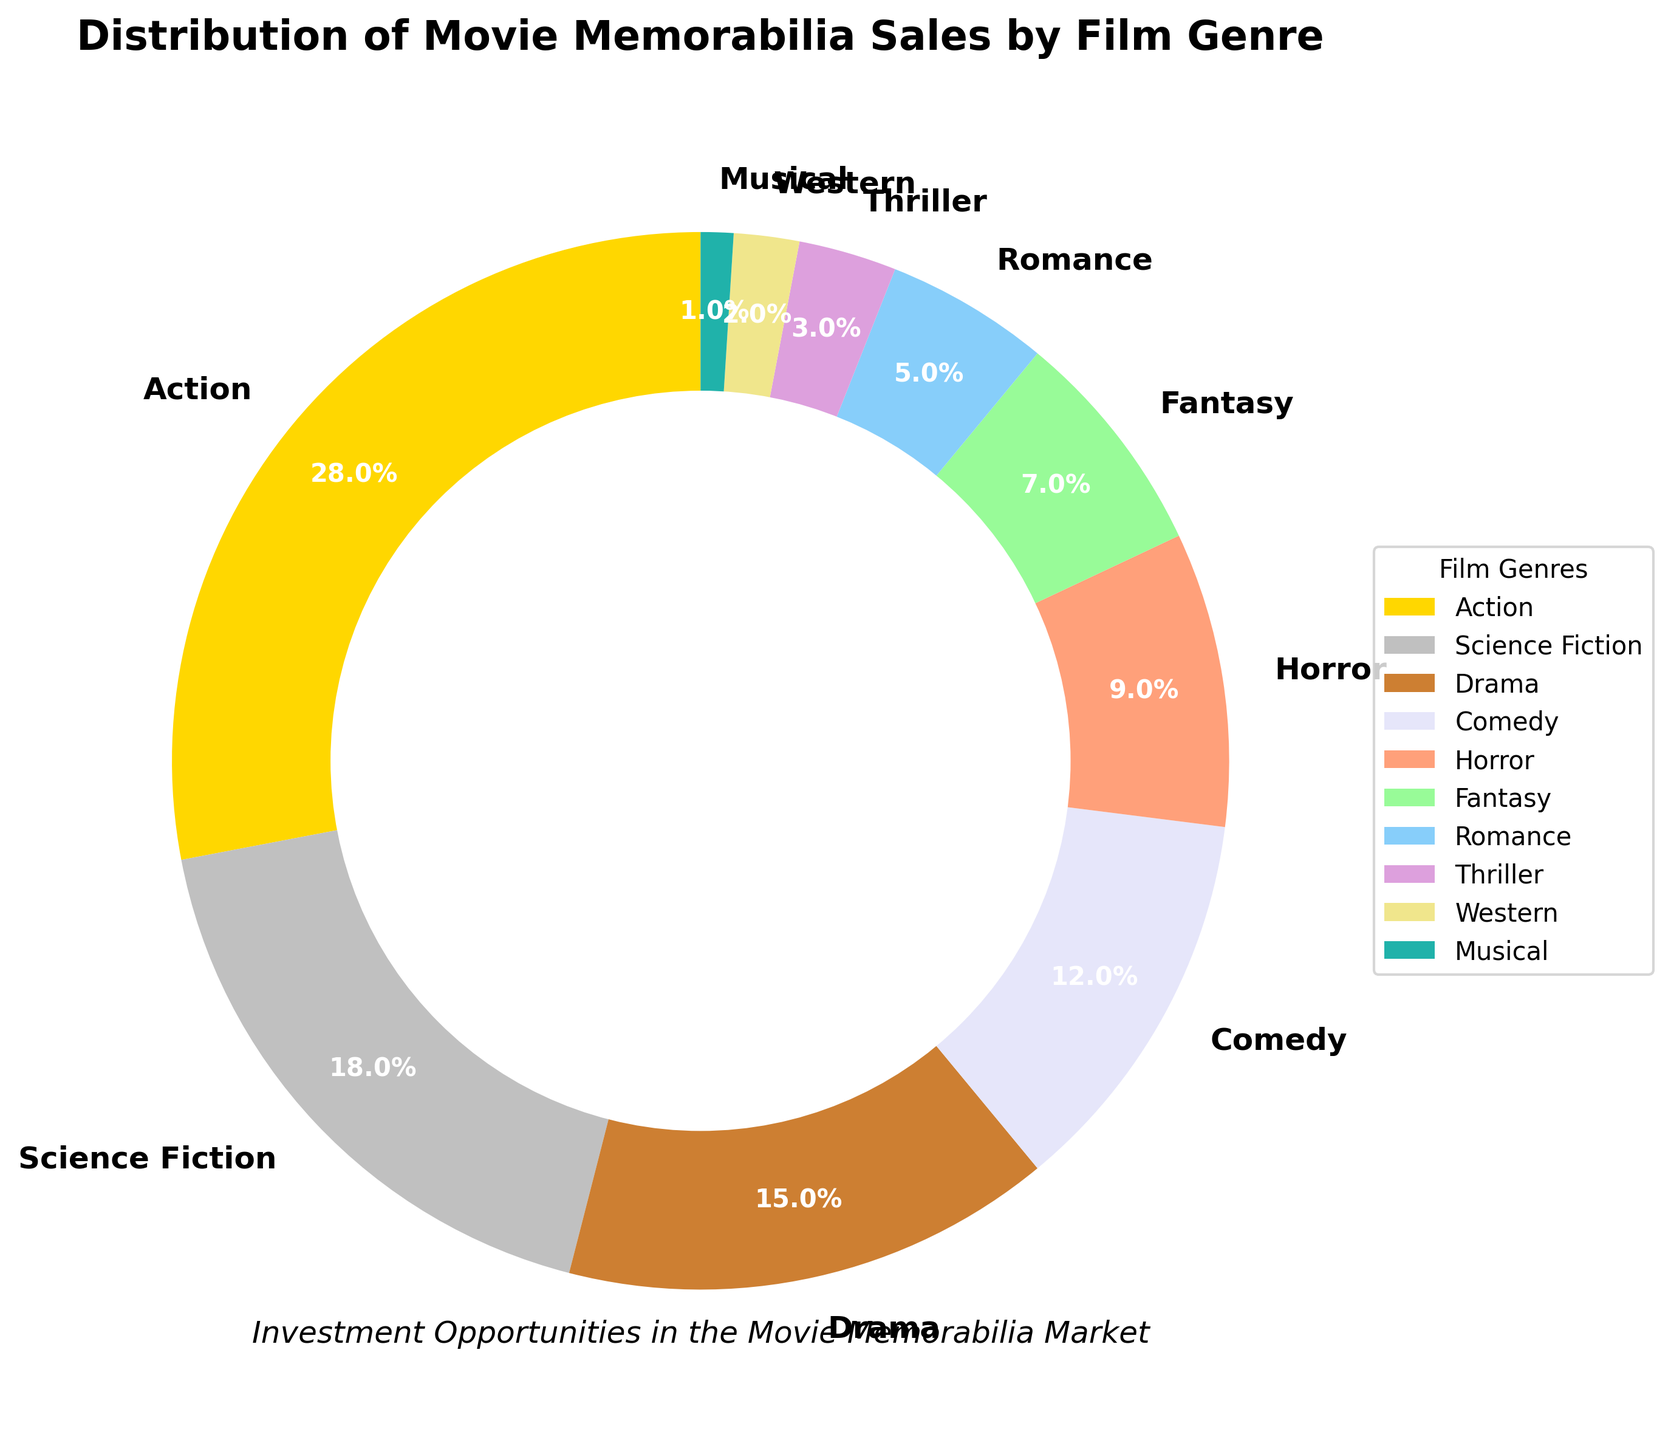Which genre has the highest percentage of movie memorabilia sales? The figure shows a pie chart where each wedge represents a percentage of movie memorabilia sales by genre. The largest wedge belongs to "Action" with 28%.
Answer: Action What is the combined market share of Science Fiction and Fantasy genres? According to the figure, Science Fiction has 18% and Fantasy has 7%. Adding these percentages gives 18 + 7 = 25%.
Answer: 25% Is the market share of Drama greater than Comedy? Based on the figure, Drama has 15% while Comedy has 12%. Since 15% is greater than 12%, Drama has a greater market share than Comedy.
Answer: Yes Which genre has a lower market share than Horror but higher than Musical? The figure shows Horror at 9% and Musical at 1%. The genre between these two percentages is Romance with 5%.
Answer: Romance Which three genres have the smallest market shares? According to the figure, the smallest wedges are Western (2%), Musical (1%), and Thriller (3%).
Answer: Western, Musical, Thriller How does the market share of Fantasy compare to that of Horror and Comedy combined? Fantasy has 7%. Horror is 9% and Comedy is 12%, so their combined share is 9 + 12 = 21%. Since 21% is greater than 7%, the combined market share of Horror and Comedy is higher than that of Fantasy.
Answer: Less than What's the difference in market share between the largest and smallest genres? The largest genre, Action, has 28%. The smallest genre, Musical, has 1%. The difference is 28 - 1 = 27%.
Answer: 27% What fraction of the total market do Western and Musical genres together represent? Western has 2% and Musical has 1%. Their total market share is 2 + 1 = 3%.
Answer: 3% Which color represents the Comedy genre in the chart? In the figure, the wedge labeled as "Comedy" corresponds to the light salmon color.
Answer: Light salmon Are the combined market shares of Action and Science Fiction greater than 40%? The percentages for Action and Science Fiction are 28% and 18% respectively. Their combined market share is 28 + 18 = 46%, which is greater than 40%.
Answer: Yes 